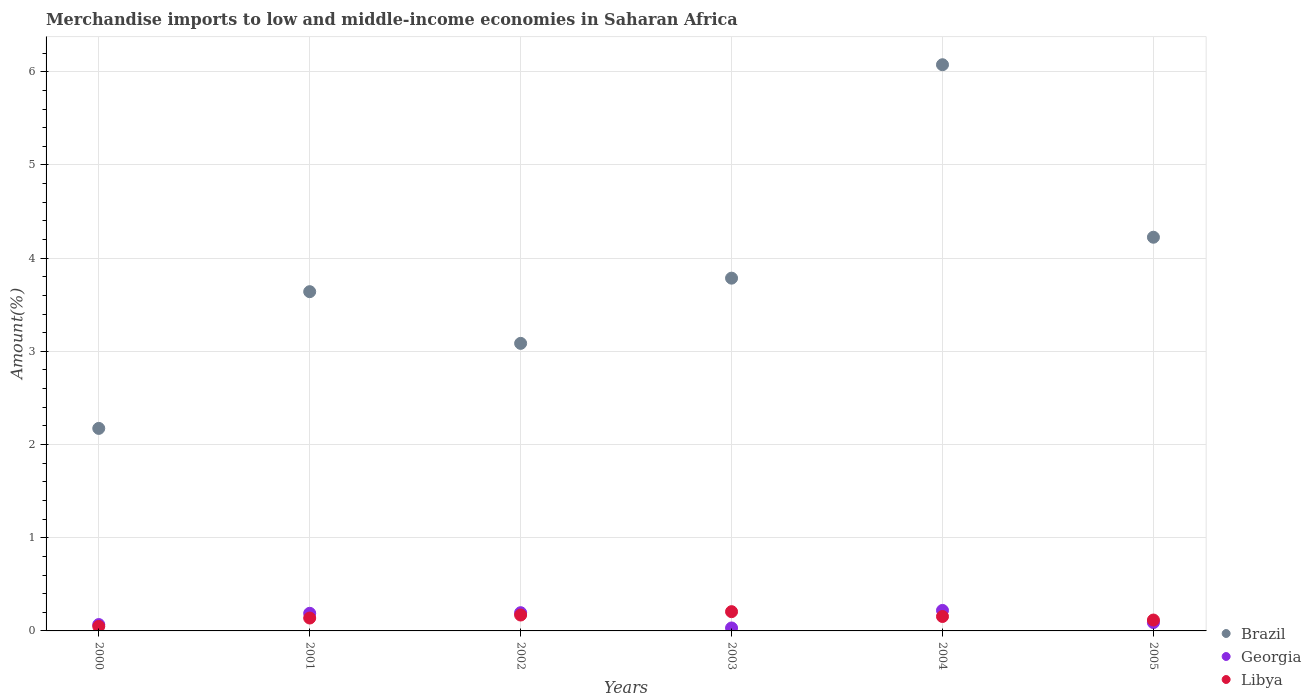How many different coloured dotlines are there?
Your answer should be compact. 3. What is the percentage of amount earned from merchandise imports in Georgia in 2004?
Your response must be concise. 0.22. Across all years, what is the maximum percentage of amount earned from merchandise imports in Georgia?
Keep it short and to the point. 0.22. Across all years, what is the minimum percentage of amount earned from merchandise imports in Georgia?
Make the answer very short. 0.03. In which year was the percentage of amount earned from merchandise imports in Georgia maximum?
Provide a succinct answer. 2004. In which year was the percentage of amount earned from merchandise imports in Libya minimum?
Ensure brevity in your answer.  2000. What is the total percentage of amount earned from merchandise imports in Georgia in the graph?
Keep it short and to the point. 0.79. What is the difference between the percentage of amount earned from merchandise imports in Georgia in 2000 and that in 2001?
Provide a short and direct response. -0.12. What is the difference between the percentage of amount earned from merchandise imports in Georgia in 2004 and the percentage of amount earned from merchandise imports in Brazil in 2002?
Your answer should be very brief. -2.87. What is the average percentage of amount earned from merchandise imports in Libya per year?
Ensure brevity in your answer.  0.14. In the year 2000, what is the difference between the percentage of amount earned from merchandise imports in Libya and percentage of amount earned from merchandise imports in Georgia?
Give a very brief answer. -0.02. What is the ratio of the percentage of amount earned from merchandise imports in Georgia in 2001 to that in 2004?
Provide a succinct answer. 0.86. Is the percentage of amount earned from merchandise imports in Libya in 2004 less than that in 2005?
Make the answer very short. No. Is the difference between the percentage of amount earned from merchandise imports in Libya in 2000 and 2002 greater than the difference between the percentage of amount earned from merchandise imports in Georgia in 2000 and 2002?
Your answer should be very brief. Yes. What is the difference between the highest and the second highest percentage of amount earned from merchandise imports in Libya?
Make the answer very short. 0.04. What is the difference between the highest and the lowest percentage of amount earned from merchandise imports in Georgia?
Keep it short and to the point. 0.19. In how many years, is the percentage of amount earned from merchandise imports in Libya greater than the average percentage of amount earned from merchandise imports in Libya taken over all years?
Keep it short and to the point. 3. Does the percentage of amount earned from merchandise imports in Georgia monotonically increase over the years?
Offer a terse response. No. Is the percentage of amount earned from merchandise imports in Brazil strictly less than the percentage of amount earned from merchandise imports in Georgia over the years?
Ensure brevity in your answer.  No. How many dotlines are there?
Your answer should be very brief. 3. What is the difference between two consecutive major ticks on the Y-axis?
Your answer should be very brief. 1. Does the graph contain any zero values?
Ensure brevity in your answer.  No. Where does the legend appear in the graph?
Keep it short and to the point. Bottom right. How are the legend labels stacked?
Your response must be concise. Vertical. What is the title of the graph?
Provide a succinct answer. Merchandise imports to low and middle-income economies in Saharan Africa. Does "Cote d'Ivoire" appear as one of the legend labels in the graph?
Keep it short and to the point. No. What is the label or title of the Y-axis?
Keep it short and to the point. Amount(%). What is the Amount(%) of Brazil in 2000?
Keep it short and to the point. 2.17. What is the Amount(%) of Georgia in 2000?
Provide a succinct answer. 0.07. What is the Amount(%) in Libya in 2000?
Your answer should be very brief. 0.05. What is the Amount(%) in Brazil in 2001?
Give a very brief answer. 3.64. What is the Amount(%) in Georgia in 2001?
Keep it short and to the point. 0.19. What is the Amount(%) in Libya in 2001?
Ensure brevity in your answer.  0.14. What is the Amount(%) in Brazil in 2002?
Keep it short and to the point. 3.09. What is the Amount(%) of Georgia in 2002?
Your answer should be compact. 0.2. What is the Amount(%) in Libya in 2002?
Ensure brevity in your answer.  0.17. What is the Amount(%) of Brazil in 2003?
Make the answer very short. 3.79. What is the Amount(%) in Georgia in 2003?
Provide a short and direct response. 0.03. What is the Amount(%) of Libya in 2003?
Provide a succinct answer. 0.21. What is the Amount(%) in Brazil in 2004?
Your answer should be compact. 6.08. What is the Amount(%) in Georgia in 2004?
Your response must be concise. 0.22. What is the Amount(%) in Libya in 2004?
Provide a succinct answer. 0.15. What is the Amount(%) of Brazil in 2005?
Provide a short and direct response. 4.22. What is the Amount(%) of Georgia in 2005?
Keep it short and to the point. 0.09. What is the Amount(%) of Libya in 2005?
Offer a terse response. 0.12. Across all years, what is the maximum Amount(%) in Brazil?
Offer a terse response. 6.08. Across all years, what is the maximum Amount(%) in Georgia?
Provide a short and direct response. 0.22. Across all years, what is the maximum Amount(%) of Libya?
Make the answer very short. 0.21. Across all years, what is the minimum Amount(%) in Brazil?
Your response must be concise. 2.17. Across all years, what is the minimum Amount(%) in Georgia?
Your answer should be compact. 0.03. Across all years, what is the minimum Amount(%) in Libya?
Your answer should be compact. 0.05. What is the total Amount(%) of Brazil in the graph?
Your answer should be compact. 22.98. What is the total Amount(%) of Georgia in the graph?
Offer a very short reply. 0.79. What is the total Amount(%) in Libya in the graph?
Your answer should be very brief. 0.84. What is the difference between the Amount(%) in Brazil in 2000 and that in 2001?
Keep it short and to the point. -1.47. What is the difference between the Amount(%) of Georgia in 2000 and that in 2001?
Offer a very short reply. -0.12. What is the difference between the Amount(%) in Libya in 2000 and that in 2001?
Make the answer very short. -0.09. What is the difference between the Amount(%) of Brazil in 2000 and that in 2002?
Provide a short and direct response. -0.91. What is the difference between the Amount(%) in Georgia in 2000 and that in 2002?
Offer a very short reply. -0.13. What is the difference between the Amount(%) of Libya in 2000 and that in 2002?
Your answer should be very brief. -0.12. What is the difference between the Amount(%) in Brazil in 2000 and that in 2003?
Give a very brief answer. -1.61. What is the difference between the Amount(%) in Georgia in 2000 and that in 2003?
Offer a very short reply. 0.04. What is the difference between the Amount(%) of Libya in 2000 and that in 2003?
Ensure brevity in your answer.  -0.16. What is the difference between the Amount(%) in Brazil in 2000 and that in 2004?
Your answer should be very brief. -3.9. What is the difference between the Amount(%) of Georgia in 2000 and that in 2004?
Offer a very short reply. -0.15. What is the difference between the Amount(%) in Libya in 2000 and that in 2004?
Offer a terse response. -0.11. What is the difference between the Amount(%) in Brazil in 2000 and that in 2005?
Your answer should be compact. -2.05. What is the difference between the Amount(%) in Georgia in 2000 and that in 2005?
Provide a short and direct response. -0.02. What is the difference between the Amount(%) in Libya in 2000 and that in 2005?
Give a very brief answer. -0.07. What is the difference between the Amount(%) in Brazil in 2001 and that in 2002?
Provide a succinct answer. 0.55. What is the difference between the Amount(%) of Georgia in 2001 and that in 2002?
Keep it short and to the point. -0.01. What is the difference between the Amount(%) in Libya in 2001 and that in 2002?
Provide a succinct answer. -0.03. What is the difference between the Amount(%) of Brazil in 2001 and that in 2003?
Your answer should be very brief. -0.14. What is the difference between the Amount(%) in Georgia in 2001 and that in 2003?
Your answer should be very brief. 0.16. What is the difference between the Amount(%) of Libya in 2001 and that in 2003?
Offer a very short reply. -0.07. What is the difference between the Amount(%) of Brazil in 2001 and that in 2004?
Give a very brief answer. -2.44. What is the difference between the Amount(%) in Georgia in 2001 and that in 2004?
Your response must be concise. -0.03. What is the difference between the Amount(%) of Libya in 2001 and that in 2004?
Make the answer very short. -0.02. What is the difference between the Amount(%) of Brazil in 2001 and that in 2005?
Ensure brevity in your answer.  -0.58. What is the difference between the Amount(%) in Georgia in 2001 and that in 2005?
Keep it short and to the point. 0.1. What is the difference between the Amount(%) in Libya in 2001 and that in 2005?
Offer a terse response. 0.02. What is the difference between the Amount(%) in Brazil in 2002 and that in 2003?
Keep it short and to the point. -0.7. What is the difference between the Amount(%) in Georgia in 2002 and that in 2003?
Provide a short and direct response. 0.16. What is the difference between the Amount(%) of Libya in 2002 and that in 2003?
Provide a short and direct response. -0.04. What is the difference between the Amount(%) of Brazil in 2002 and that in 2004?
Your response must be concise. -2.99. What is the difference between the Amount(%) in Georgia in 2002 and that in 2004?
Offer a very short reply. -0.02. What is the difference between the Amount(%) of Libya in 2002 and that in 2004?
Make the answer very short. 0.02. What is the difference between the Amount(%) of Brazil in 2002 and that in 2005?
Offer a terse response. -1.14. What is the difference between the Amount(%) in Georgia in 2002 and that in 2005?
Give a very brief answer. 0.11. What is the difference between the Amount(%) in Libya in 2002 and that in 2005?
Your answer should be very brief. 0.05. What is the difference between the Amount(%) in Brazil in 2003 and that in 2004?
Your answer should be compact. -2.29. What is the difference between the Amount(%) in Georgia in 2003 and that in 2004?
Your answer should be compact. -0.19. What is the difference between the Amount(%) in Libya in 2003 and that in 2004?
Provide a short and direct response. 0.05. What is the difference between the Amount(%) in Brazil in 2003 and that in 2005?
Give a very brief answer. -0.44. What is the difference between the Amount(%) in Georgia in 2003 and that in 2005?
Provide a succinct answer. -0.06. What is the difference between the Amount(%) in Libya in 2003 and that in 2005?
Your answer should be very brief. 0.09. What is the difference between the Amount(%) of Brazil in 2004 and that in 2005?
Keep it short and to the point. 1.85. What is the difference between the Amount(%) of Georgia in 2004 and that in 2005?
Your answer should be very brief. 0.13. What is the difference between the Amount(%) of Libya in 2004 and that in 2005?
Provide a short and direct response. 0.04. What is the difference between the Amount(%) of Brazil in 2000 and the Amount(%) of Georgia in 2001?
Ensure brevity in your answer.  1.98. What is the difference between the Amount(%) in Brazil in 2000 and the Amount(%) in Libya in 2001?
Your answer should be compact. 2.03. What is the difference between the Amount(%) in Georgia in 2000 and the Amount(%) in Libya in 2001?
Provide a short and direct response. -0.07. What is the difference between the Amount(%) in Brazil in 2000 and the Amount(%) in Georgia in 2002?
Ensure brevity in your answer.  1.98. What is the difference between the Amount(%) in Brazil in 2000 and the Amount(%) in Libya in 2002?
Your answer should be very brief. 2. What is the difference between the Amount(%) in Georgia in 2000 and the Amount(%) in Libya in 2002?
Your answer should be compact. -0.1. What is the difference between the Amount(%) in Brazil in 2000 and the Amount(%) in Georgia in 2003?
Offer a very short reply. 2.14. What is the difference between the Amount(%) of Brazil in 2000 and the Amount(%) of Libya in 2003?
Offer a terse response. 1.97. What is the difference between the Amount(%) of Georgia in 2000 and the Amount(%) of Libya in 2003?
Keep it short and to the point. -0.14. What is the difference between the Amount(%) in Brazil in 2000 and the Amount(%) in Georgia in 2004?
Keep it short and to the point. 1.95. What is the difference between the Amount(%) in Brazil in 2000 and the Amount(%) in Libya in 2004?
Offer a terse response. 2.02. What is the difference between the Amount(%) of Georgia in 2000 and the Amount(%) of Libya in 2004?
Ensure brevity in your answer.  -0.09. What is the difference between the Amount(%) in Brazil in 2000 and the Amount(%) in Georgia in 2005?
Your response must be concise. 2.08. What is the difference between the Amount(%) in Brazil in 2000 and the Amount(%) in Libya in 2005?
Ensure brevity in your answer.  2.06. What is the difference between the Amount(%) of Georgia in 2000 and the Amount(%) of Libya in 2005?
Your answer should be very brief. -0.05. What is the difference between the Amount(%) in Brazil in 2001 and the Amount(%) in Georgia in 2002?
Ensure brevity in your answer.  3.44. What is the difference between the Amount(%) in Brazil in 2001 and the Amount(%) in Libya in 2002?
Provide a succinct answer. 3.47. What is the difference between the Amount(%) of Georgia in 2001 and the Amount(%) of Libya in 2002?
Make the answer very short. 0.02. What is the difference between the Amount(%) in Brazil in 2001 and the Amount(%) in Georgia in 2003?
Your response must be concise. 3.61. What is the difference between the Amount(%) of Brazil in 2001 and the Amount(%) of Libya in 2003?
Your answer should be very brief. 3.43. What is the difference between the Amount(%) of Georgia in 2001 and the Amount(%) of Libya in 2003?
Give a very brief answer. -0.02. What is the difference between the Amount(%) of Brazil in 2001 and the Amount(%) of Georgia in 2004?
Provide a succinct answer. 3.42. What is the difference between the Amount(%) in Brazil in 2001 and the Amount(%) in Libya in 2004?
Provide a short and direct response. 3.49. What is the difference between the Amount(%) in Georgia in 2001 and the Amount(%) in Libya in 2004?
Provide a succinct answer. 0.03. What is the difference between the Amount(%) of Brazil in 2001 and the Amount(%) of Georgia in 2005?
Provide a short and direct response. 3.55. What is the difference between the Amount(%) of Brazil in 2001 and the Amount(%) of Libya in 2005?
Keep it short and to the point. 3.52. What is the difference between the Amount(%) of Georgia in 2001 and the Amount(%) of Libya in 2005?
Your answer should be compact. 0.07. What is the difference between the Amount(%) in Brazil in 2002 and the Amount(%) in Georgia in 2003?
Offer a terse response. 3.05. What is the difference between the Amount(%) in Brazil in 2002 and the Amount(%) in Libya in 2003?
Give a very brief answer. 2.88. What is the difference between the Amount(%) in Georgia in 2002 and the Amount(%) in Libya in 2003?
Give a very brief answer. -0.01. What is the difference between the Amount(%) of Brazil in 2002 and the Amount(%) of Georgia in 2004?
Your answer should be compact. 2.87. What is the difference between the Amount(%) in Brazil in 2002 and the Amount(%) in Libya in 2004?
Your answer should be compact. 2.93. What is the difference between the Amount(%) of Georgia in 2002 and the Amount(%) of Libya in 2004?
Provide a succinct answer. 0.04. What is the difference between the Amount(%) in Brazil in 2002 and the Amount(%) in Georgia in 2005?
Provide a short and direct response. 3. What is the difference between the Amount(%) of Brazil in 2002 and the Amount(%) of Libya in 2005?
Provide a short and direct response. 2.97. What is the difference between the Amount(%) of Georgia in 2002 and the Amount(%) of Libya in 2005?
Your response must be concise. 0.08. What is the difference between the Amount(%) in Brazil in 2003 and the Amount(%) in Georgia in 2004?
Offer a terse response. 3.57. What is the difference between the Amount(%) of Brazil in 2003 and the Amount(%) of Libya in 2004?
Make the answer very short. 3.63. What is the difference between the Amount(%) of Georgia in 2003 and the Amount(%) of Libya in 2004?
Your answer should be very brief. -0.12. What is the difference between the Amount(%) in Brazil in 2003 and the Amount(%) in Georgia in 2005?
Keep it short and to the point. 3.7. What is the difference between the Amount(%) of Brazil in 2003 and the Amount(%) of Libya in 2005?
Offer a very short reply. 3.67. What is the difference between the Amount(%) of Georgia in 2003 and the Amount(%) of Libya in 2005?
Offer a terse response. -0.09. What is the difference between the Amount(%) in Brazil in 2004 and the Amount(%) in Georgia in 2005?
Ensure brevity in your answer.  5.99. What is the difference between the Amount(%) of Brazil in 2004 and the Amount(%) of Libya in 2005?
Keep it short and to the point. 5.96. What is the difference between the Amount(%) of Georgia in 2004 and the Amount(%) of Libya in 2005?
Offer a very short reply. 0.1. What is the average Amount(%) of Brazil per year?
Offer a very short reply. 3.83. What is the average Amount(%) of Georgia per year?
Your answer should be compact. 0.13. What is the average Amount(%) of Libya per year?
Offer a terse response. 0.14. In the year 2000, what is the difference between the Amount(%) of Brazil and Amount(%) of Georgia?
Offer a very short reply. 2.1. In the year 2000, what is the difference between the Amount(%) in Brazil and Amount(%) in Libya?
Ensure brevity in your answer.  2.12. In the year 2000, what is the difference between the Amount(%) of Georgia and Amount(%) of Libya?
Provide a short and direct response. 0.02. In the year 2001, what is the difference between the Amount(%) of Brazil and Amount(%) of Georgia?
Your answer should be compact. 3.45. In the year 2001, what is the difference between the Amount(%) of Brazil and Amount(%) of Libya?
Provide a succinct answer. 3.5. In the year 2001, what is the difference between the Amount(%) of Georgia and Amount(%) of Libya?
Give a very brief answer. 0.05. In the year 2002, what is the difference between the Amount(%) of Brazil and Amount(%) of Georgia?
Your answer should be compact. 2.89. In the year 2002, what is the difference between the Amount(%) in Brazil and Amount(%) in Libya?
Provide a short and direct response. 2.92. In the year 2002, what is the difference between the Amount(%) in Georgia and Amount(%) in Libya?
Your answer should be very brief. 0.03. In the year 2003, what is the difference between the Amount(%) of Brazil and Amount(%) of Georgia?
Offer a very short reply. 3.75. In the year 2003, what is the difference between the Amount(%) of Brazil and Amount(%) of Libya?
Provide a succinct answer. 3.58. In the year 2003, what is the difference between the Amount(%) of Georgia and Amount(%) of Libya?
Give a very brief answer. -0.17. In the year 2004, what is the difference between the Amount(%) of Brazil and Amount(%) of Georgia?
Offer a very short reply. 5.86. In the year 2004, what is the difference between the Amount(%) of Brazil and Amount(%) of Libya?
Your answer should be compact. 5.92. In the year 2004, what is the difference between the Amount(%) of Georgia and Amount(%) of Libya?
Ensure brevity in your answer.  0.07. In the year 2005, what is the difference between the Amount(%) in Brazil and Amount(%) in Georgia?
Provide a succinct answer. 4.13. In the year 2005, what is the difference between the Amount(%) in Brazil and Amount(%) in Libya?
Keep it short and to the point. 4.11. In the year 2005, what is the difference between the Amount(%) in Georgia and Amount(%) in Libya?
Your answer should be very brief. -0.03. What is the ratio of the Amount(%) of Brazil in 2000 to that in 2001?
Ensure brevity in your answer.  0.6. What is the ratio of the Amount(%) of Georgia in 2000 to that in 2001?
Your response must be concise. 0.36. What is the ratio of the Amount(%) of Libya in 2000 to that in 2001?
Offer a terse response. 0.35. What is the ratio of the Amount(%) in Brazil in 2000 to that in 2002?
Ensure brevity in your answer.  0.7. What is the ratio of the Amount(%) in Georgia in 2000 to that in 2002?
Provide a short and direct response. 0.35. What is the ratio of the Amount(%) of Libya in 2000 to that in 2002?
Provide a succinct answer. 0.29. What is the ratio of the Amount(%) of Brazil in 2000 to that in 2003?
Provide a short and direct response. 0.57. What is the ratio of the Amount(%) in Georgia in 2000 to that in 2003?
Offer a very short reply. 2.15. What is the ratio of the Amount(%) of Libya in 2000 to that in 2003?
Give a very brief answer. 0.24. What is the ratio of the Amount(%) in Brazil in 2000 to that in 2004?
Your answer should be very brief. 0.36. What is the ratio of the Amount(%) in Georgia in 2000 to that in 2004?
Provide a succinct answer. 0.31. What is the ratio of the Amount(%) of Libya in 2000 to that in 2004?
Provide a succinct answer. 0.31. What is the ratio of the Amount(%) in Brazil in 2000 to that in 2005?
Keep it short and to the point. 0.51. What is the ratio of the Amount(%) in Georgia in 2000 to that in 2005?
Make the answer very short. 0.76. What is the ratio of the Amount(%) in Libya in 2000 to that in 2005?
Offer a terse response. 0.42. What is the ratio of the Amount(%) in Brazil in 2001 to that in 2002?
Give a very brief answer. 1.18. What is the ratio of the Amount(%) in Georgia in 2001 to that in 2002?
Your answer should be very brief. 0.97. What is the ratio of the Amount(%) of Libya in 2001 to that in 2002?
Offer a very short reply. 0.81. What is the ratio of the Amount(%) of Brazil in 2001 to that in 2003?
Provide a short and direct response. 0.96. What is the ratio of the Amount(%) of Georgia in 2001 to that in 2003?
Your answer should be very brief. 5.97. What is the ratio of the Amount(%) of Libya in 2001 to that in 2003?
Offer a very short reply. 0.67. What is the ratio of the Amount(%) of Brazil in 2001 to that in 2004?
Ensure brevity in your answer.  0.6. What is the ratio of the Amount(%) of Georgia in 2001 to that in 2004?
Ensure brevity in your answer.  0.86. What is the ratio of the Amount(%) of Libya in 2001 to that in 2004?
Ensure brevity in your answer.  0.89. What is the ratio of the Amount(%) in Brazil in 2001 to that in 2005?
Give a very brief answer. 0.86. What is the ratio of the Amount(%) in Georgia in 2001 to that in 2005?
Provide a short and direct response. 2.11. What is the ratio of the Amount(%) in Libya in 2001 to that in 2005?
Your response must be concise. 1.18. What is the ratio of the Amount(%) in Brazil in 2002 to that in 2003?
Provide a short and direct response. 0.82. What is the ratio of the Amount(%) of Georgia in 2002 to that in 2003?
Your answer should be very brief. 6.18. What is the ratio of the Amount(%) of Libya in 2002 to that in 2003?
Keep it short and to the point. 0.83. What is the ratio of the Amount(%) in Brazil in 2002 to that in 2004?
Offer a terse response. 0.51. What is the ratio of the Amount(%) in Georgia in 2002 to that in 2004?
Give a very brief answer. 0.89. What is the ratio of the Amount(%) in Libya in 2002 to that in 2004?
Ensure brevity in your answer.  1.1. What is the ratio of the Amount(%) of Brazil in 2002 to that in 2005?
Provide a short and direct response. 0.73. What is the ratio of the Amount(%) in Georgia in 2002 to that in 2005?
Offer a very short reply. 2.18. What is the ratio of the Amount(%) in Libya in 2002 to that in 2005?
Keep it short and to the point. 1.46. What is the ratio of the Amount(%) in Brazil in 2003 to that in 2004?
Your answer should be compact. 0.62. What is the ratio of the Amount(%) in Georgia in 2003 to that in 2004?
Your response must be concise. 0.14. What is the ratio of the Amount(%) in Libya in 2003 to that in 2004?
Ensure brevity in your answer.  1.33. What is the ratio of the Amount(%) in Brazil in 2003 to that in 2005?
Make the answer very short. 0.9. What is the ratio of the Amount(%) in Georgia in 2003 to that in 2005?
Your answer should be compact. 0.35. What is the ratio of the Amount(%) in Libya in 2003 to that in 2005?
Give a very brief answer. 1.77. What is the ratio of the Amount(%) in Brazil in 2004 to that in 2005?
Your answer should be very brief. 1.44. What is the ratio of the Amount(%) of Georgia in 2004 to that in 2005?
Your answer should be very brief. 2.46. What is the ratio of the Amount(%) of Libya in 2004 to that in 2005?
Offer a terse response. 1.33. What is the difference between the highest and the second highest Amount(%) of Brazil?
Your answer should be compact. 1.85. What is the difference between the highest and the second highest Amount(%) of Georgia?
Give a very brief answer. 0.02. What is the difference between the highest and the second highest Amount(%) of Libya?
Provide a short and direct response. 0.04. What is the difference between the highest and the lowest Amount(%) of Brazil?
Give a very brief answer. 3.9. What is the difference between the highest and the lowest Amount(%) of Georgia?
Ensure brevity in your answer.  0.19. What is the difference between the highest and the lowest Amount(%) of Libya?
Ensure brevity in your answer.  0.16. 